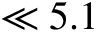<formula> <loc_0><loc_0><loc_500><loc_500>\ll 5 . 1</formula> 